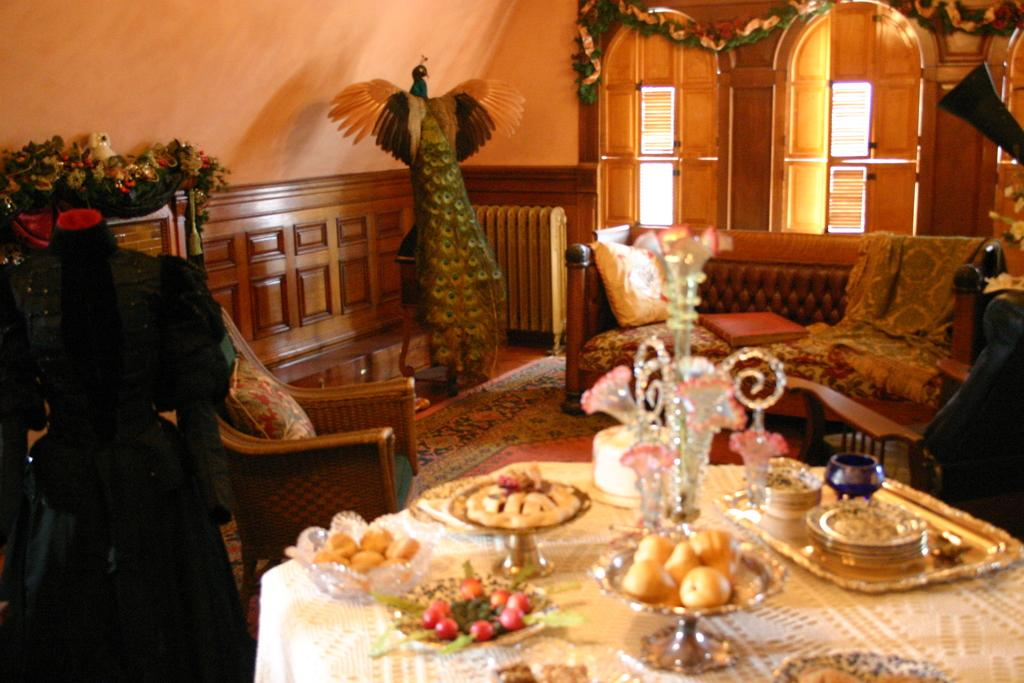What type of furniture is present in the image? There is a sofa and a chair in the image. What can be found on the table in the image? There are food items on a table in the image. What architectural features can be seen in the image? There are windows and a wall in the image. Can you describe any other objects in the image? There are other unspecified objects in the image. What type of carriage is visible in the image? There is no carriage present in the image. What type of approval is being sought in the image? There is no indication of approval being sought in the image. 